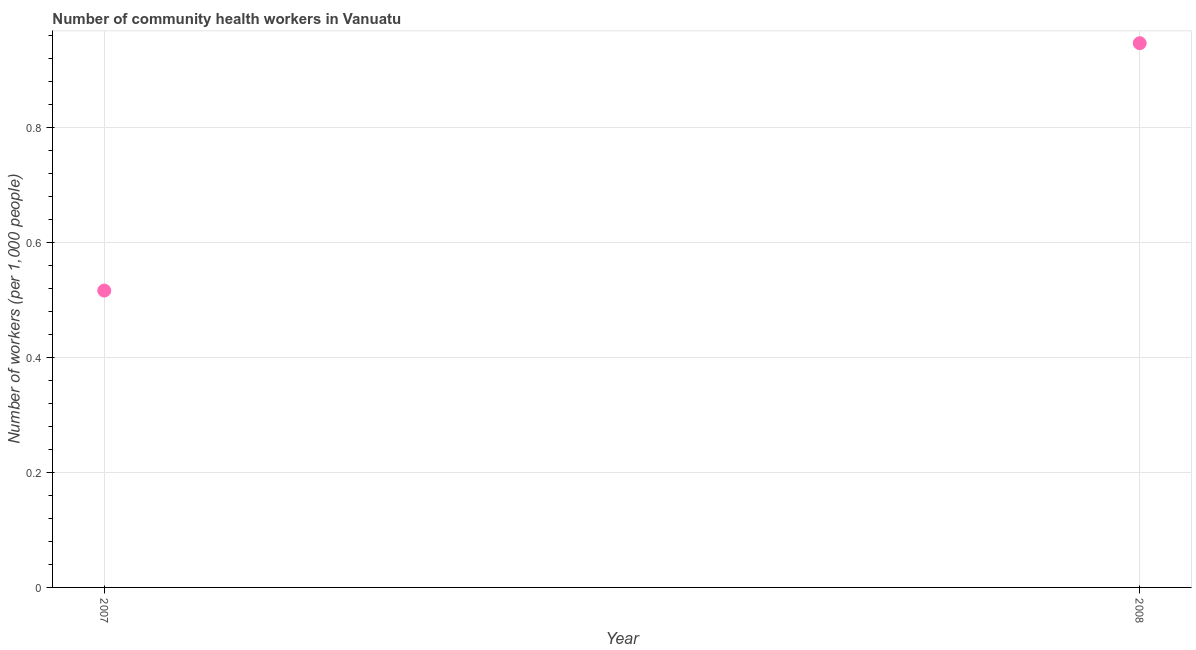What is the number of community health workers in 2008?
Your answer should be very brief. 0.95. Across all years, what is the maximum number of community health workers?
Make the answer very short. 0.95. Across all years, what is the minimum number of community health workers?
Your response must be concise. 0.52. In which year was the number of community health workers minimum?
Make the answer very short. 2007. What is the sum of the number of community health workers?
Provide a short and direct response. 1.46. What is the difference between the number of community health workers in 2007 and 2008?
Your response must be concise. -0.43. What is the average number of community health workers per year?
Your answer should be very brief. 0.73. What is the median number of community health workers?
Offer a terse response. 0.73. Do a majority of the years between 2007 and 2008 (inclusive) have number of community health workers greater than 0.04 ?
Ensure brevity in your answer.  Yes. What is the ratio of the number of community health workers in 2007 to that in 2008?
Offer a very short reply. 0.55. Does the number of community health workers monotonically increase over the years?
Your answer should be very brief. Yes. How many dotlines are there?
Ensure brevity in your answer.  1. How many years are there in the graph?
Offer a terse response. 2. Are the values on the major ticks of Y-axis written in scientific E-notation?
Offer a very short reply. No. What is the title of the graph?
Your answer should be very brief. Number of community health workers in Vanuatu. What is the label or title of the Y-axis?
Provide a succinct answer. Number of workers (per 1,0 people). What is the Number of workers (per 1,000 people) in 2007?
Your response must be concise. 0.52. What is the Number of workers (per 1,000 people) in 2008?
Offer a terse response. 0.95. What is the difference between the Number of workers (per 1,000 people) in 2007 and 2008?
Offer a very short reply. -0.43. What is the ratio of the Number of workers (per 1,000 people) in 2007 to that in 2008?
Make the answer very short. 0.55. 